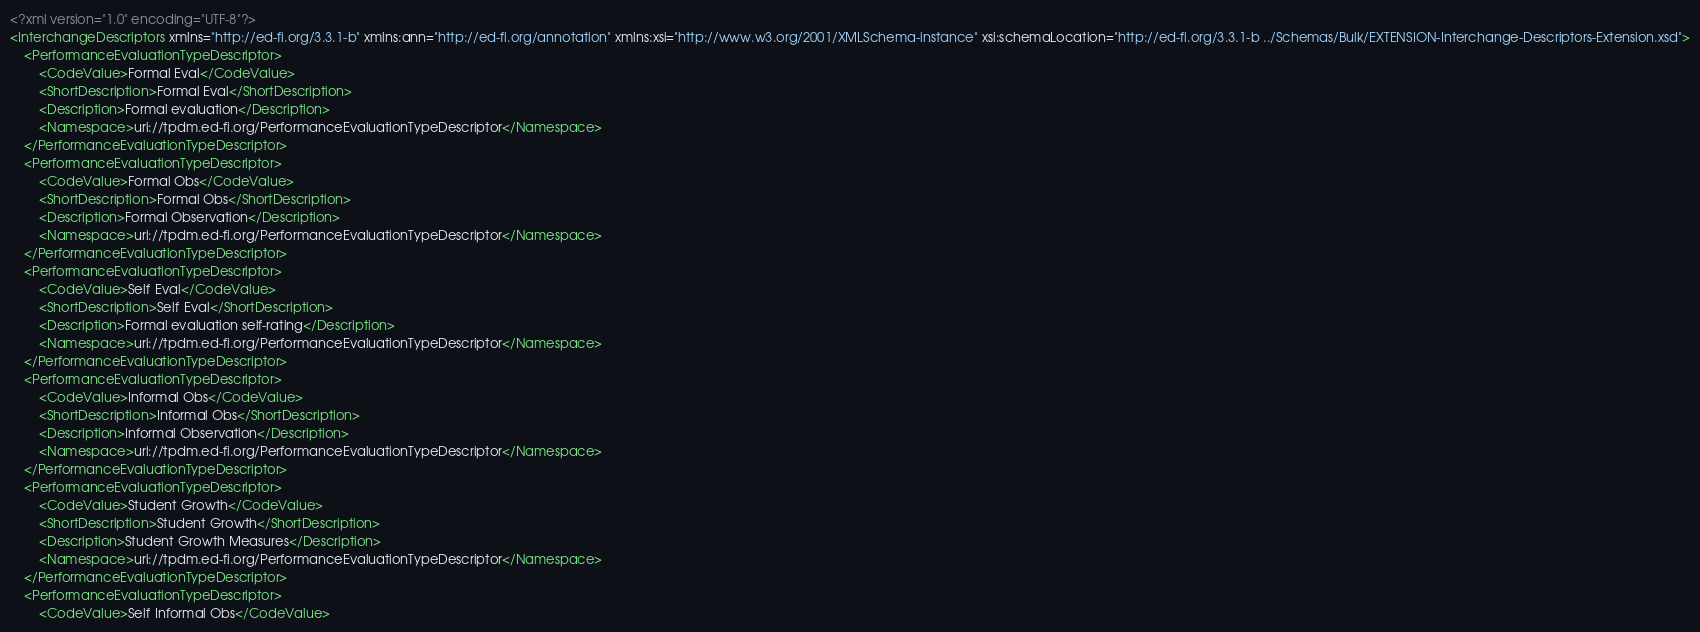<code> <loc_0><loc_0><loc_500><loc_500><_XML_><?xml version="1.0" encoding="UTF-8"?>
<InterchangeDescriptors xmlns="http://ed-fi.org/3.3.1-b" xmlns:ann="http://ed-fi.org/annotation" xmlns:xsi="http://www.w3.org/2001/XMLSchema-instance" xsi:schemaLocation="http://ed-fi.org/3.3.1-b ../Schemas/Bulk/EXTENSION-Interchange-Descriptors-Extension.xsd">
	<PerformanceEvaluationTypeDescriptor>
		<CodeValue>Formal Eval</CodeValue>
		<ShortDescription>Formal Eval</ShortDescription>
		<Description>Formal evaluation</Description>
		<Namespace>uri://tpdm.ed-fi.org/PerformanceEvaluationTypeDescriptor</Namespace>
	</PerformanceEvaluationTypeDescriptor>
	<PerformanceEvaluationTypeDescriptor>
		<CodeValue>Formal Obs</CodeValue>
		<ShortDescription>Formal Obs</ShortDescription>
		<Description>Formal Observation</Description>
		<Namespace>uri://tpdm.ed-fi.org/PerformanceEvaluationTypeDescriptor</Namespace>
	</PerformanceEvaluationTypeDescriptor>
	<PerformanceEvaluationTypeDescriptor>
		<CodeValue>Self Eval</CodeValue>
		<ShortDescription>Self Eval</ShortDescription>
		<Description>Formal evaluation self-rating</Description>
		<Namespace>uri://tpdm.ed-fi.org/PerformanceEvaluationTypeDescriptor</Namespace>
	</PerformanceEvaluationTypeDescriptor>
	<PerformanceEvaluationTypeDescriptor>
		<CodeValue>Informal Obs</CodeValue>
		<ShortDescription>Informal Obs</ShortDescription>
		<Description>Informal Observation</Description>
		<Namespace>uri://tpdm.ed-fi.org/PerformanceEvaluationTypeDescriptor</Namespace>
	</PerformanceEvaluationTypeDescriptor>
	<PerformanceEvaluationTypeDescriptor>
		<CodeValue>Student Growth</CodeValue>
		<ShortDescription>Student Growth</ShortDescription>
		<Description>Student Growth Measures</Description>
		<Namespace>uri://tpdm.ed-fi.org/PerformanceEvaluationTypeDescriptor</Namespace>
	</PerformanceEvaluationTypeDescriptor>
	<PerformanceEvaluationTypeDescriptor>
		<CodeValue>Self Informal Obs</CodeValue></code> 